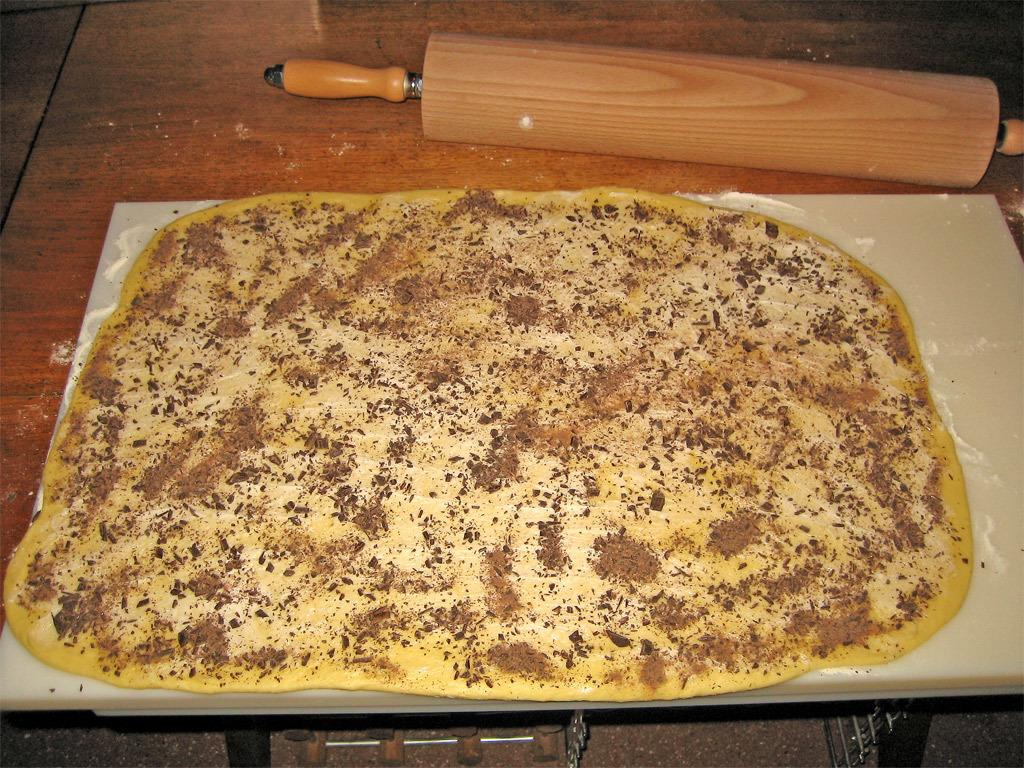What type of food item can be seen in the image? There is a food item in the image, but its specific type cannot be determined from the provided facts. What surface is the food item placed on? The food item is placed on a chopping board in the image. What is the chopping board resting on? The chopping board is on a wooden object in the image. What else can be seen behind the wooden object? There is another item visible behind the wooden object, but its specific type cannot be determined from the provided facts. What experiences do the brothers share in the image? There is no mention of brothers or any shared experiences in the image. 